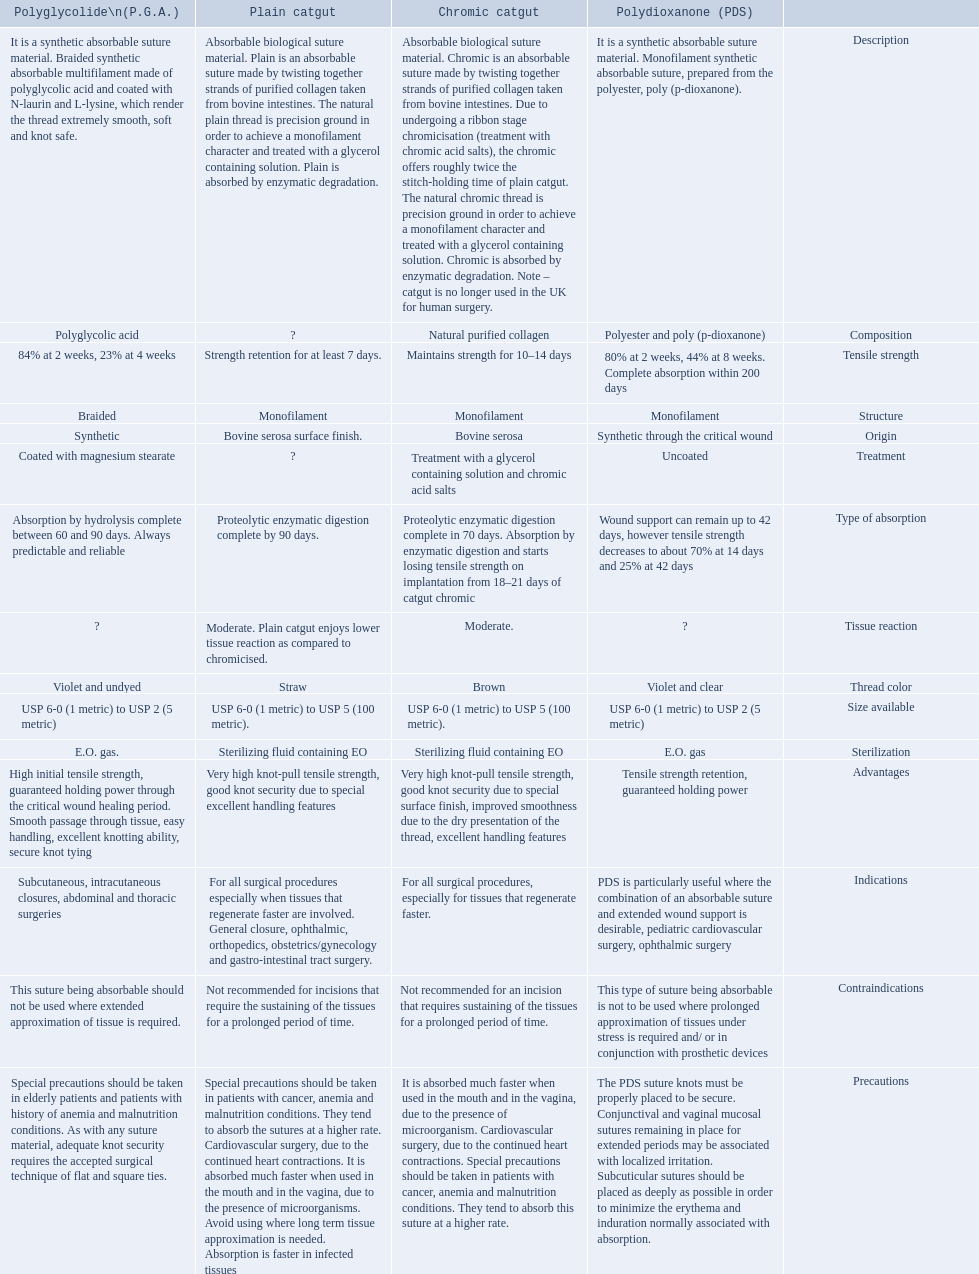Which are the different tensile strengths of the suture materials in the comparison chart? Strength retention for at least 7 days., Maintains strength for 10–14 days, 84% at 2 weeks, 23% at 4 weeks, 80% at 2 weeks, 44% at 8 weeks. Complete absorption within 200 days. Of these, which belongs to plain catgut? Strength retention for at least 7 days. 